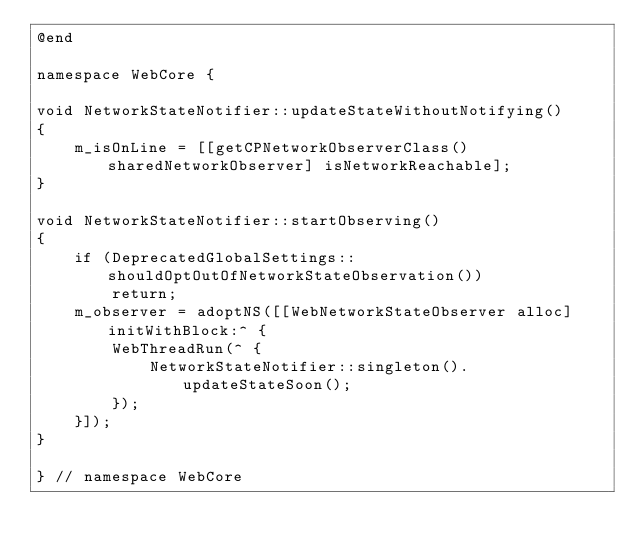<code> <loc_0><loc_0><loc_500><loc_500><_ObjectiveC_>@end

namespace WebCore {

void NetworkStateNotifier::updateStateWithoutNotifying()
{
    m_isOnLine = [[getCPNetworkObserverClass() sharedNetworkObserver] isNetworkReachable];
}

void NetworkStateNotifier::startObserving()
{
    if (DeprecatedGlobalSettings::shouldOptOutOfNetworkStateObservation())
        return;
    m_observer = adoptNS([[WebNetworkStateObserver alloc] initWithBlock:^ {
        WebThreadRun(^ {
            NetworkStateNotifier::singleton().updateStateSoon();
        });
    }]);
}

} // namespace WebCore
</code> 